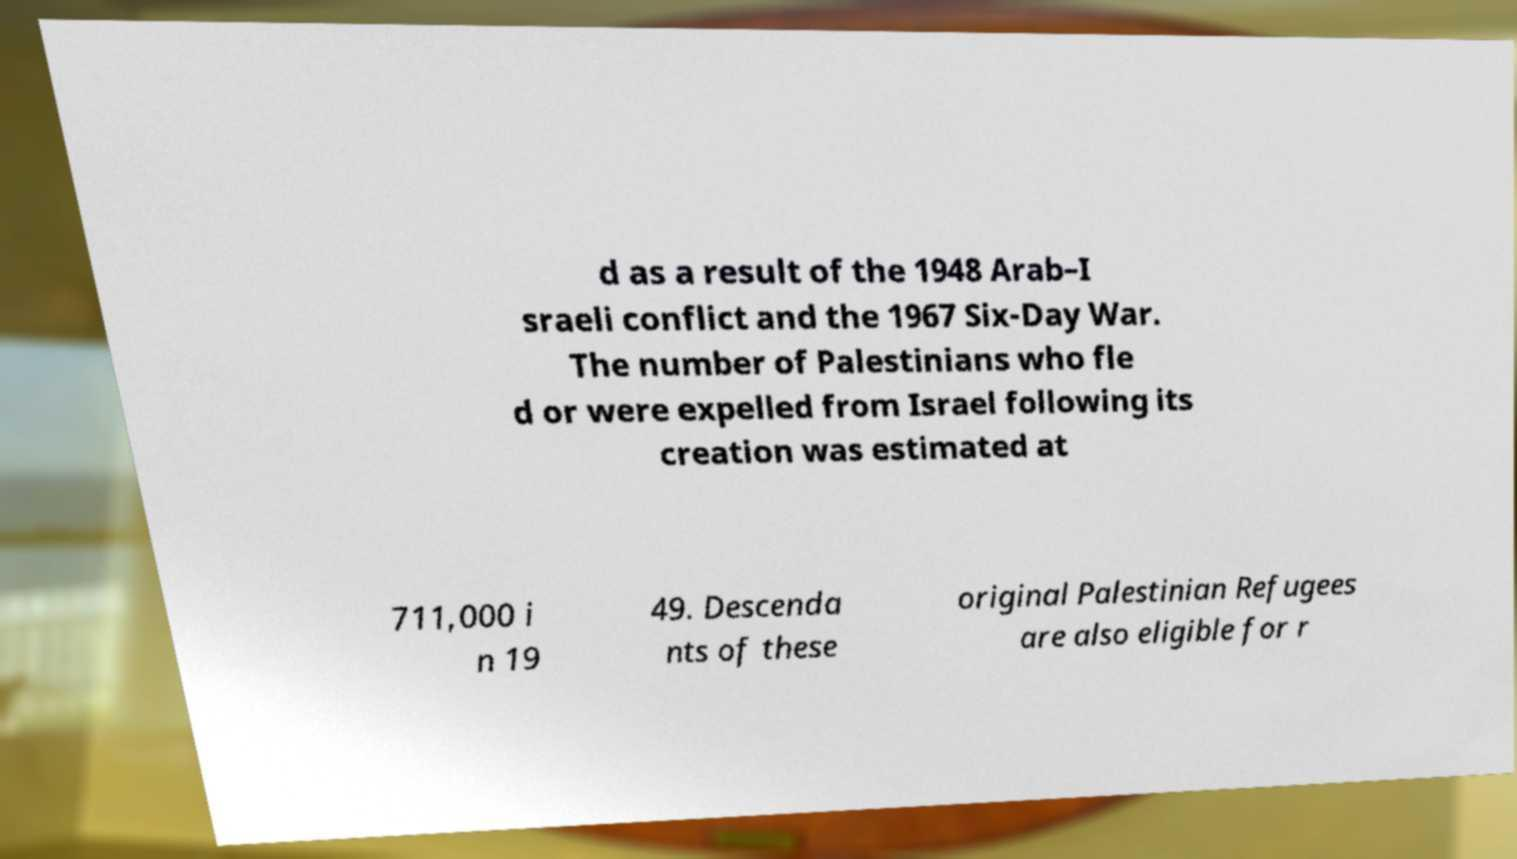What messages or text are displayed in this image? I need them in a readable, typed format. d as a result of the 1948 Arab–I sraeli conflict and the 1967 Six-Day War. The number of Palestinians who fle d or were expelled from Israel following its creation was estimated at 711,000 i n 19 49. Descenda nts of these original Palestinian Refugees are also eligible for r 